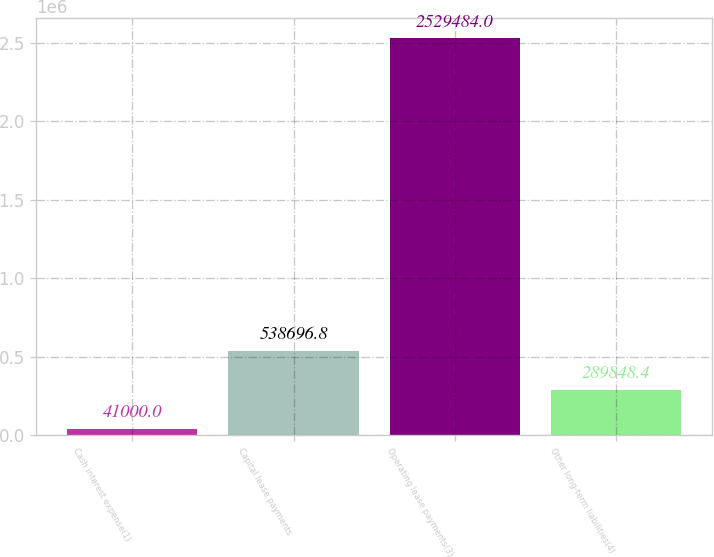Convert chart to OTSL. <chart><loc_0><loc_0><loc_500><loc_500><bar_chart><fcel>Cash interest expense(1)<fcel>Capital lease payments<fcel>Operating lease payments(3)<fcel>Other long-term liabilities(4)<nl><fcel>41000<fcel>538697<fcel>2.52948e+06<fcel>289848<nl></chart> 